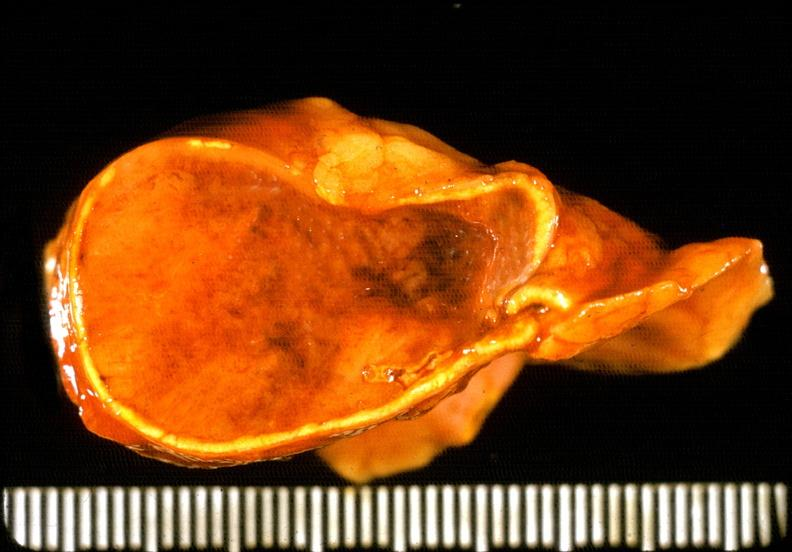does this image show adrenal phaeochromocytoma?
Answer the question using a single word or phrase. Yes 